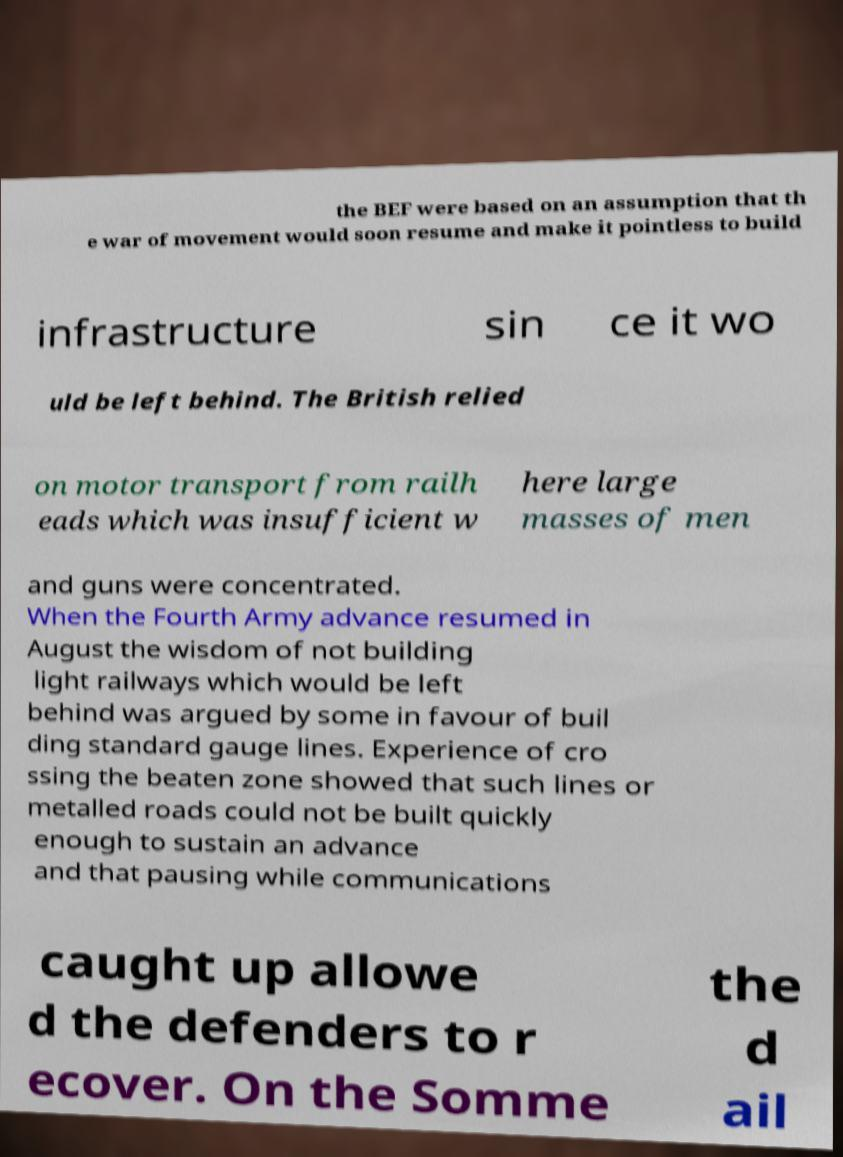What messages or text are displayed in this image? I need them in a readable, typed format. the BEF were based on an assumption that th e war of movement would soon resume and make it pointless to build infrastructure sin ce it wo uld be left behind. The British relied on motor transport from railh eads which was insufficient w here large masses of men and guns were concentrated. When the Fourth Army advance resumed in August the wisdom of not building light railways which would be left behind was argued by some in favour of buil ding standard gauge lines. Experience of cro ssing the beaten zone showed that such lines or metalled roads could not be built quickly enough to sustain an advance and that pausing while communications caught up allowe d the defenders to r ecover. On the Somme the d ail 